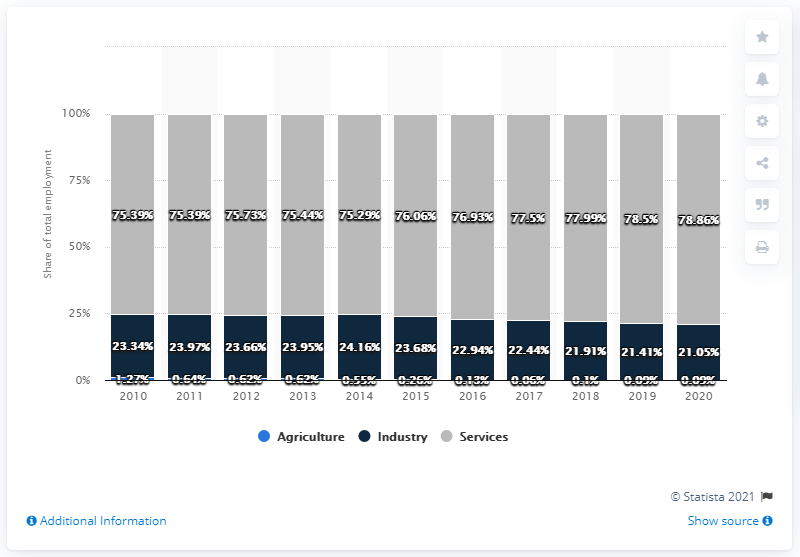Specify some key components in this picture. The difference between the highest services and the highest industry is 54.7%. 